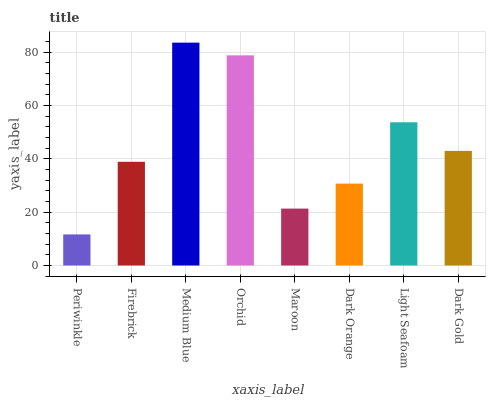Is Periwinkle the minimum?
Answer yes or no. Yes. Is Medium Blue the maximum?
Answer yes or no. Yes. Is Firebrick the minimum?
Answer yes or no. No. Is Firebrick the maximum?
Answer yes or no. No. Is Firebrick greater than Periwinkle?
Answer yes or no. Yes. Is Periwinkle less than Firebrick?
Answer yes or no. Yes. Is Periwinkle greater than Firebrick?
Answer yes or no. No. Is Firebrick less than Periwinkle?
Answer yes or no. No. Is Dark Gold the high median?
Answer yes or no. Yes. Is Firebrick the low median?
Answer yes or no. Yes. Is Maroon the high median?
Answer yes or no. No. Is Light Seafoam the low median?
Answer yes or no. No. 